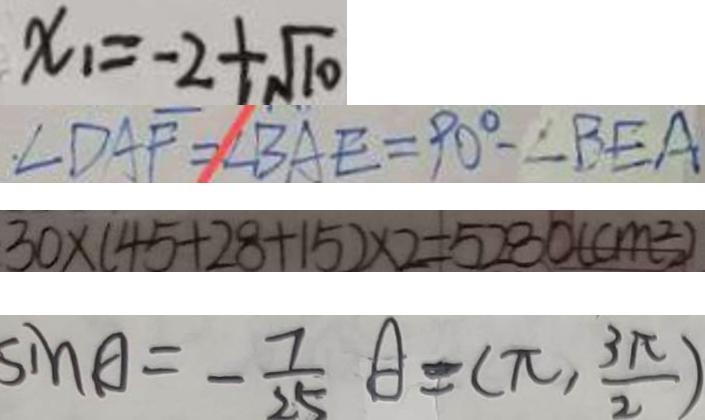Convert formula to latex. <formula><loc_0><loc_0><loc_500><loc_500>x _ { 1 } = - 2 + \sqrt { 1 0 } 
 \angle D A F = \angle B A E = 9 0 ^ { \circ } - \angle B E A 
 3 0 \times ( 4 5 + 2 8 + 1 5 ) \times 2 = 5 2 8 0 ( c m ^ { 2 } ) 
 \sin A = - \frac { 7 } { 2 5 } A = ( \pi , \frac { 3 \pi } { 2 } )</formula> 